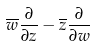Convert formula to latex. <formula><loc_0><loc_0><loc_500><loc_500>\overline { w } \frac { \partial } { \partial z } - \overline { z } \frac { \partial } { \partial w }</formula> 